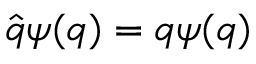Convert formula to latex. <formula><loc_0><loc_0><loc_500><loc_500>{ \hat { q } } \psi ( q ) = q \psi ( q )</formula> 